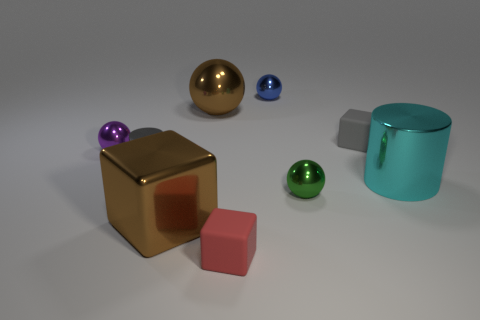Is the color of the big metal ball the same as the tiny object behind the big brown shiny sphere?
Ensure brevity in your answer.  No. Are there more big cylinders than brown rubber cylinders?
Offer a very short reply. Yes. What is the size of the blue thing that is the same shape as the small green object?
Provide a succinct answer. Small. Do the green object and the brown thing that is left of the brown metal sphere have the same material?
Offer a terse response. Yes. How many objects are large brown metal objects or large brown cubes?
Give a very brief answer. 2. Do the cylinder to the right of the tiny red object and the gray thing that is right of the metal cube have the same size?
Your answer should be compact. No. How many spheres are either gray matte things or large cyan metal objects?
Provide a succinct answer. 0. Are there any gray shiny cylinders?
Ensure brevity in your answer.  Yes. Are there any other things that are the same shape as the small purple shiny thing?
Provide a succinct answer. Yes. Is the tiny cylinder the same color as the large metal cylinder?
Make the answer very short. No. 